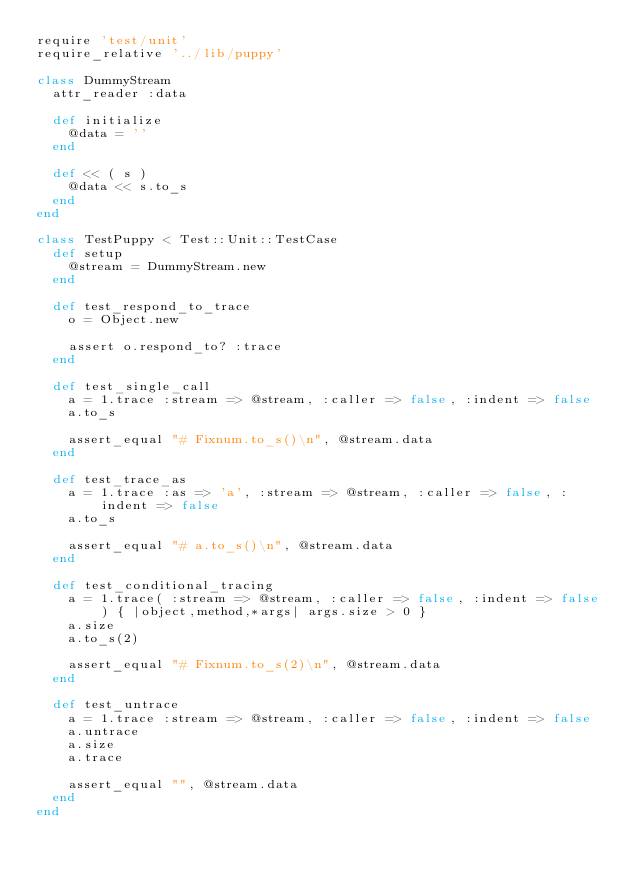<code> <loc_0><loc_0><loc_500><loc_500><_Ruby_>require 'test/unit'
require_relative '../lib/puppy'

class DummyStream
  attr_reader :data

  def initialize
    @data = ''
  end

  def << ( s )
    @data << s.to_s
  end
end

class TestPuppy < Test::Unit::TestCase
  def setup
    @stream = DummyStream.new
  end

  def test_respond_to_trace
    o = Object.new

    assert o.respond_to? :trace
  end

  def test_single_call
    a = 1.trace :stream => @stream, :caller => false, :indent => false
    a.to_s

    assert_equal "# Fixnum.to_s()\n", @stream.data
  end
  
  def test_trace_as
    a = 1.trace :as => 'a', :stream => @stream, :caller => false, :indent => false
    a.to_s

    assert_equal "# a.to_s()\n", @stream.data
  end  

  def test_conditional_tracing
    a = 1.trace( :stream => @stream, :caller => false, :indent => false ) { |object,method,*args| args.size > 0 }
    a.size
    a.to_s(2)

    assert_equal "# Fixnum.to_s(2)\n", @stream.data
  end

  def test_untrace
    a = 1.trace :stream => @stream, :caller => false, :indent => false
    a.untrace
    a.size
    a.trace

    assert_equal "", @stream.data
  end
end

</code> 